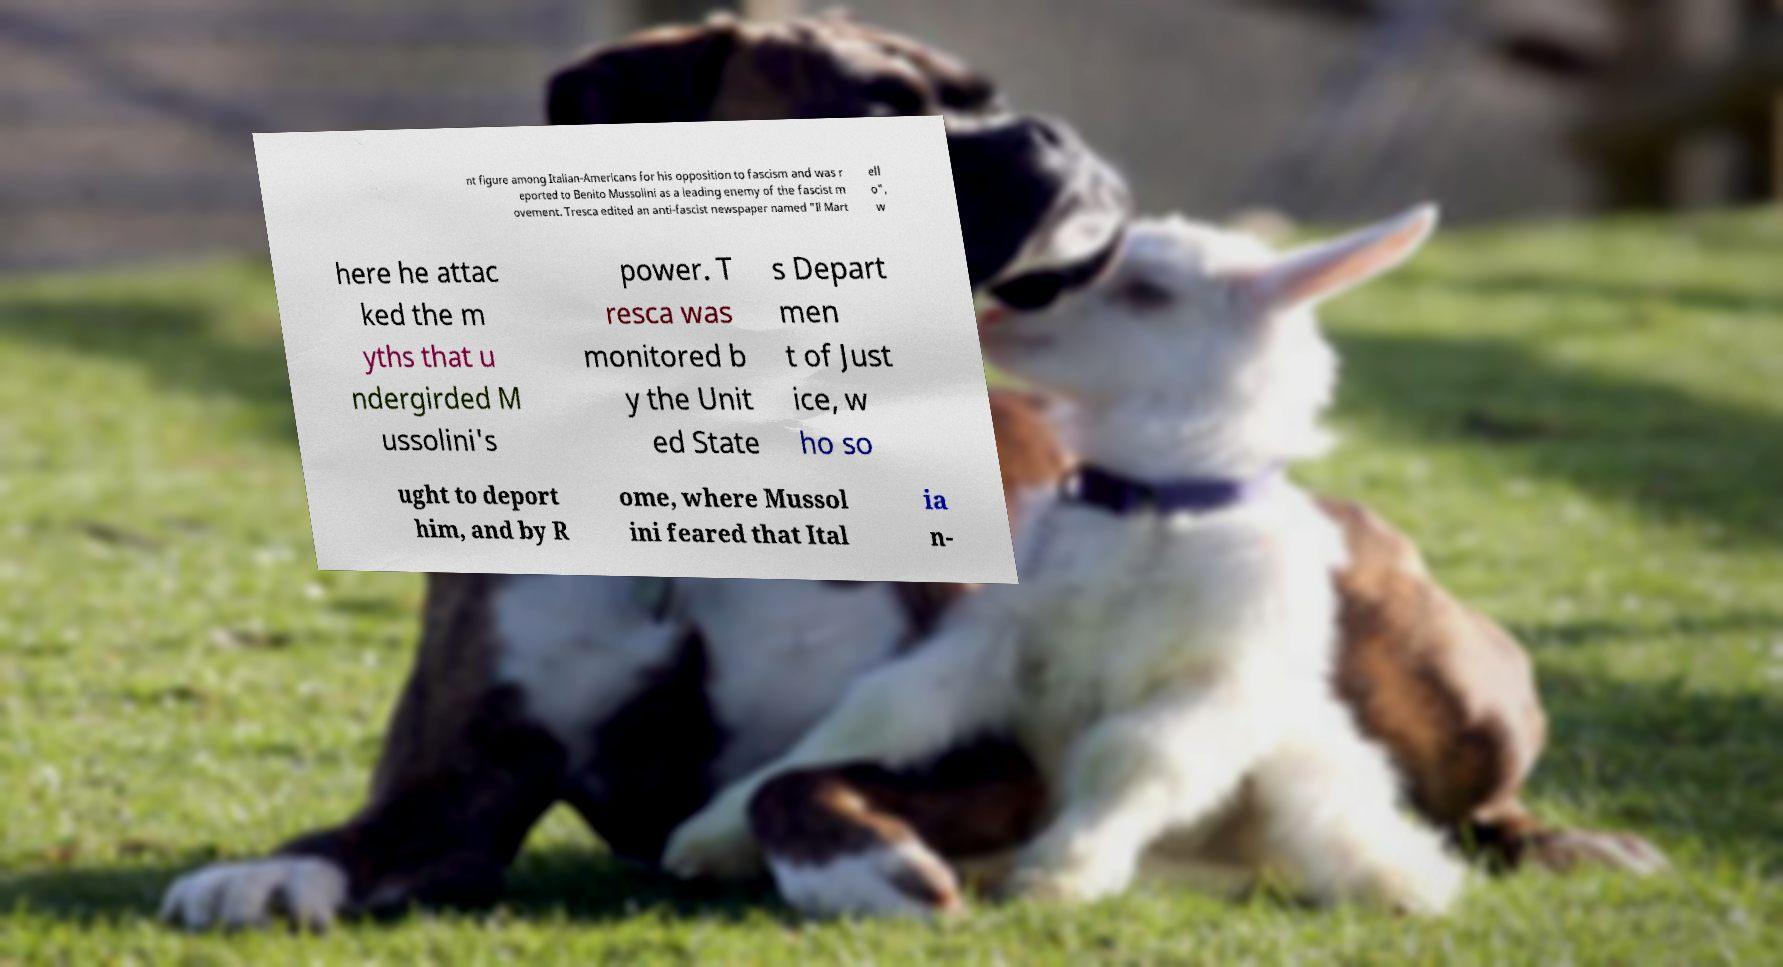For documentation purposes, I need the text within this image transcribed. Could you provide that? nt figure among Italian-Americans for his opposition to fascism and was r eported to Benito Mussolini as a leading enemy of the fascist m ovement. Tresca edited an anti-fascist newspaper named "Il Mart ell o", w here he attac ked the m yths that u ndergirded M ussolini's power. T resca was monitored b y the Unit ed State s Depart men t of Just ice, w ho so ught to deport him, and by R ome, where Mussol ini feared that Ital ia n- 